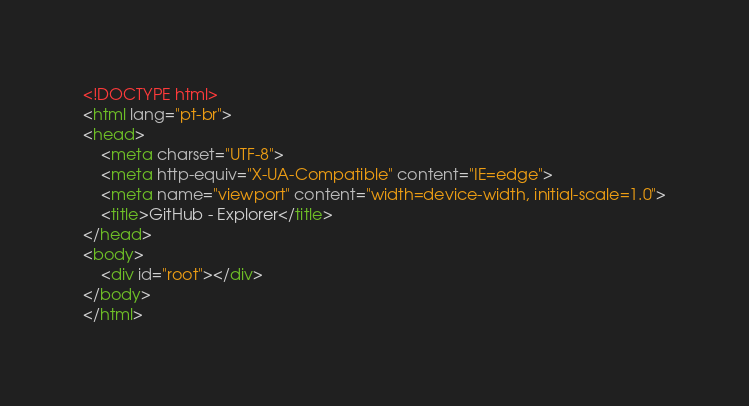<code> <loc_0><loc_0><loc_500><loc_500><_HTML_><!DOCTYPE html>
<html lang="pt-br">
<head>
    <meta charset="UTF-8">
    <meta http-equiv="X-UA-Compatible" content="IE=edge">
    <meta name="viewport" content="width=device-width, initial-scale=1.0">
    <title>GitHub - Explorer</title>
</head>
<body>
    <div id="root"></div>
</body>
</html></code> 